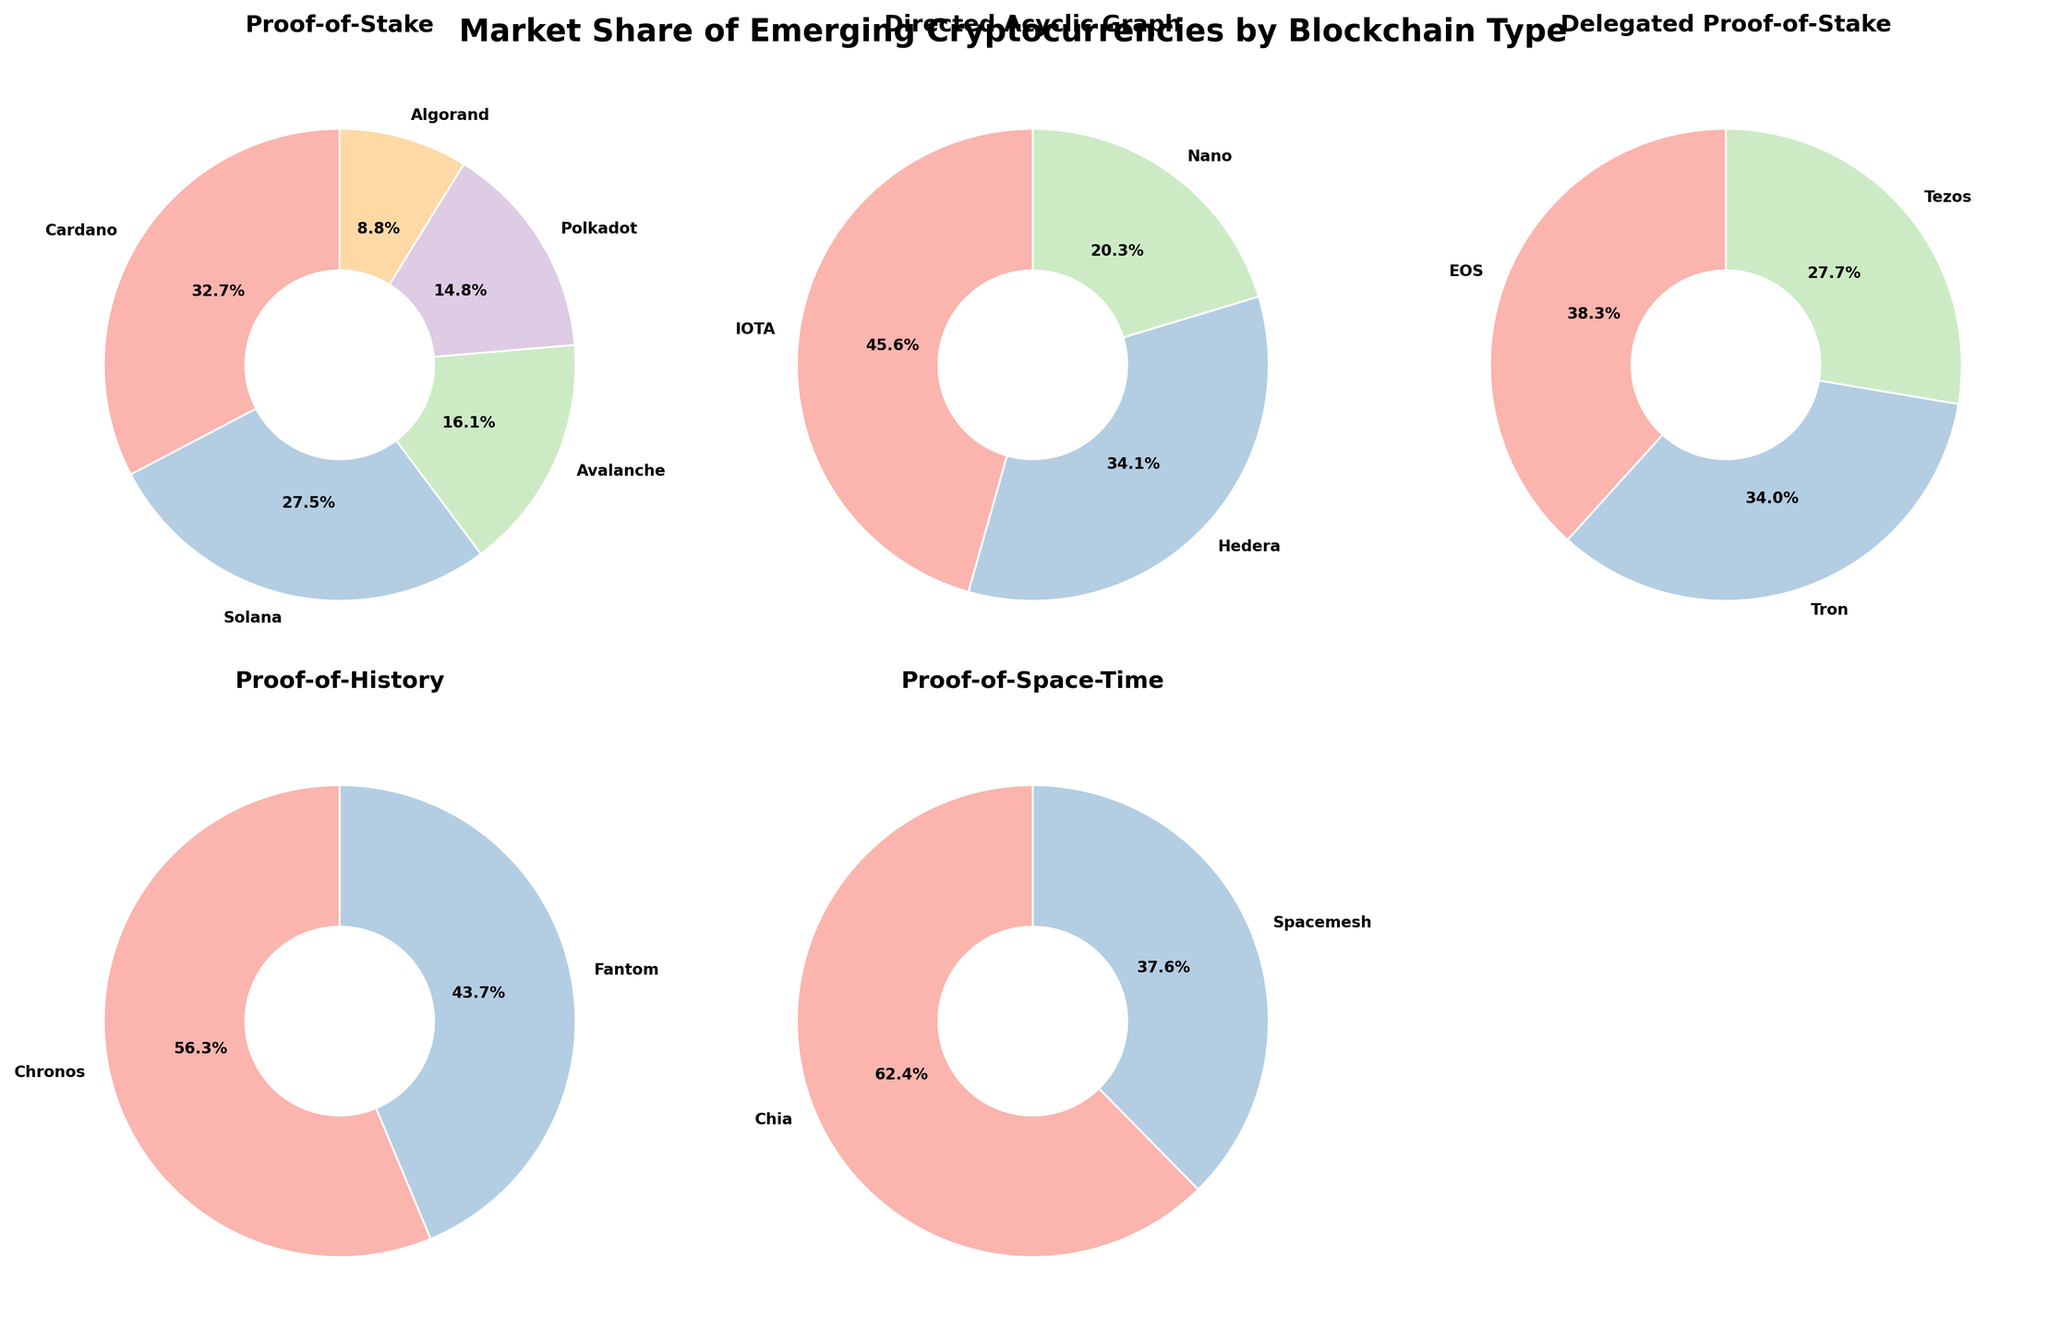What is the overall title of the figure? The title is given at the top of the figure, which usually summarizes the main information presented. In this case, it states that the figure is about market share.
Answer: Market Share of Emerging Cryptocurrencies by Blockchain Type Which blockchain type has the cryptocurrency with the highest market share? By looking through each subplot, the cryptocurrency with the highest percentage in any pie chart is Cardano. This belongs to the Proof-of-Stake blockchain type.
Answer: Proof-of-Stake What is the combined market share of all cryptocurrencies within the "Directed Acyclic Graph" blockchain type? Add the percentages of IOTA, Hedera, and Nano. Summing 8.3% + 6.2% + 3.7% gives the total market share.
Answer: 18.2% Which cryptocurrency has a higher market share, EOS or Tezos, and what are their shares? Compare the market share percentages of EOS and Tezos from the Delegated Proof-of-Stake pie chart. EOS has 5.4% while Tezos has 3.9%.
Answer: EOS has 5.4%, Tezos has 3.9% Which pie chart has the largest number of distinct cryptocurrencies? Count the distinct labels in each pie chart. The "Proof-of-Stake" pie chart contains the most cryptocurrencies with five distinct ones (Cardano, Solana, Avalanche, Polkadot, Algorand).
Answer: Proof-of-Stake What is the market share difference between Solana and Polkadot? Extract market shares of Solana and Polkadot which are 12.8% and 6.9% respectively. Find the difference, 12.8% - 6.9%.
Answer: 5.9% What blockchain type contains Chronos and what is its market share? Look for Chronos in the pie charts and note its blockchain type and the percentage. Chronos is in the Proof-of-History pie chart with a 6.7% market share.
Answer: Proof-of-History, 6.7% Which cryptocurrencies have a market share less than 5%? Identify all cryptocurrencies with percentages below 5% in each pie chart. These are Algorand (4.1%), Nano (3.7%), Tezos (3.9%), Spacemesh (3.5%), and Tron (4.8%).
Answer: Algorand, Nano, Tezos, Spacemesh, Tron What is the average market share of cryptocurrencies in the Proof-of-Space-Time category? Add the market shares of Chia (5.8%) and Spacemesh (3.5%) and then divide by 2. (5.8% + 3.5%) / 2 = 4.65%.
Answer: 4.65% How many blockchain types have more than one cryptocurrency listed? Count the pie charts showing more than one slice. There are four such pie charts: Proof-of-Stake, Directed Acyclic Graph, Delegated Proof-of-Stake, and Proof-of-Space-Time.
Answer: 4 